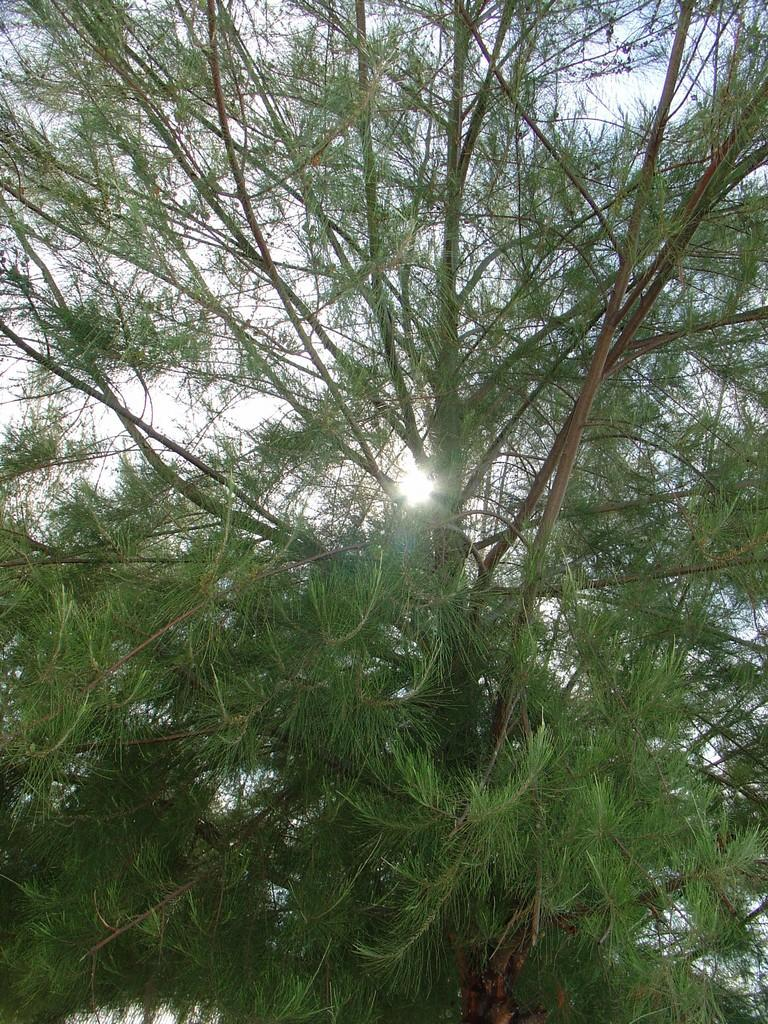What type of natural element can be seen in the image? There is a tree in the image. What else is visible in the image besides the tree? The sky is visible in the image. How would you describe the sky in the image? The sky appears to be cloudy. What is the profit margin of the tree in the image? There is no profit margin associated with the tree in the image, as it is a natural element and not a business entity. 